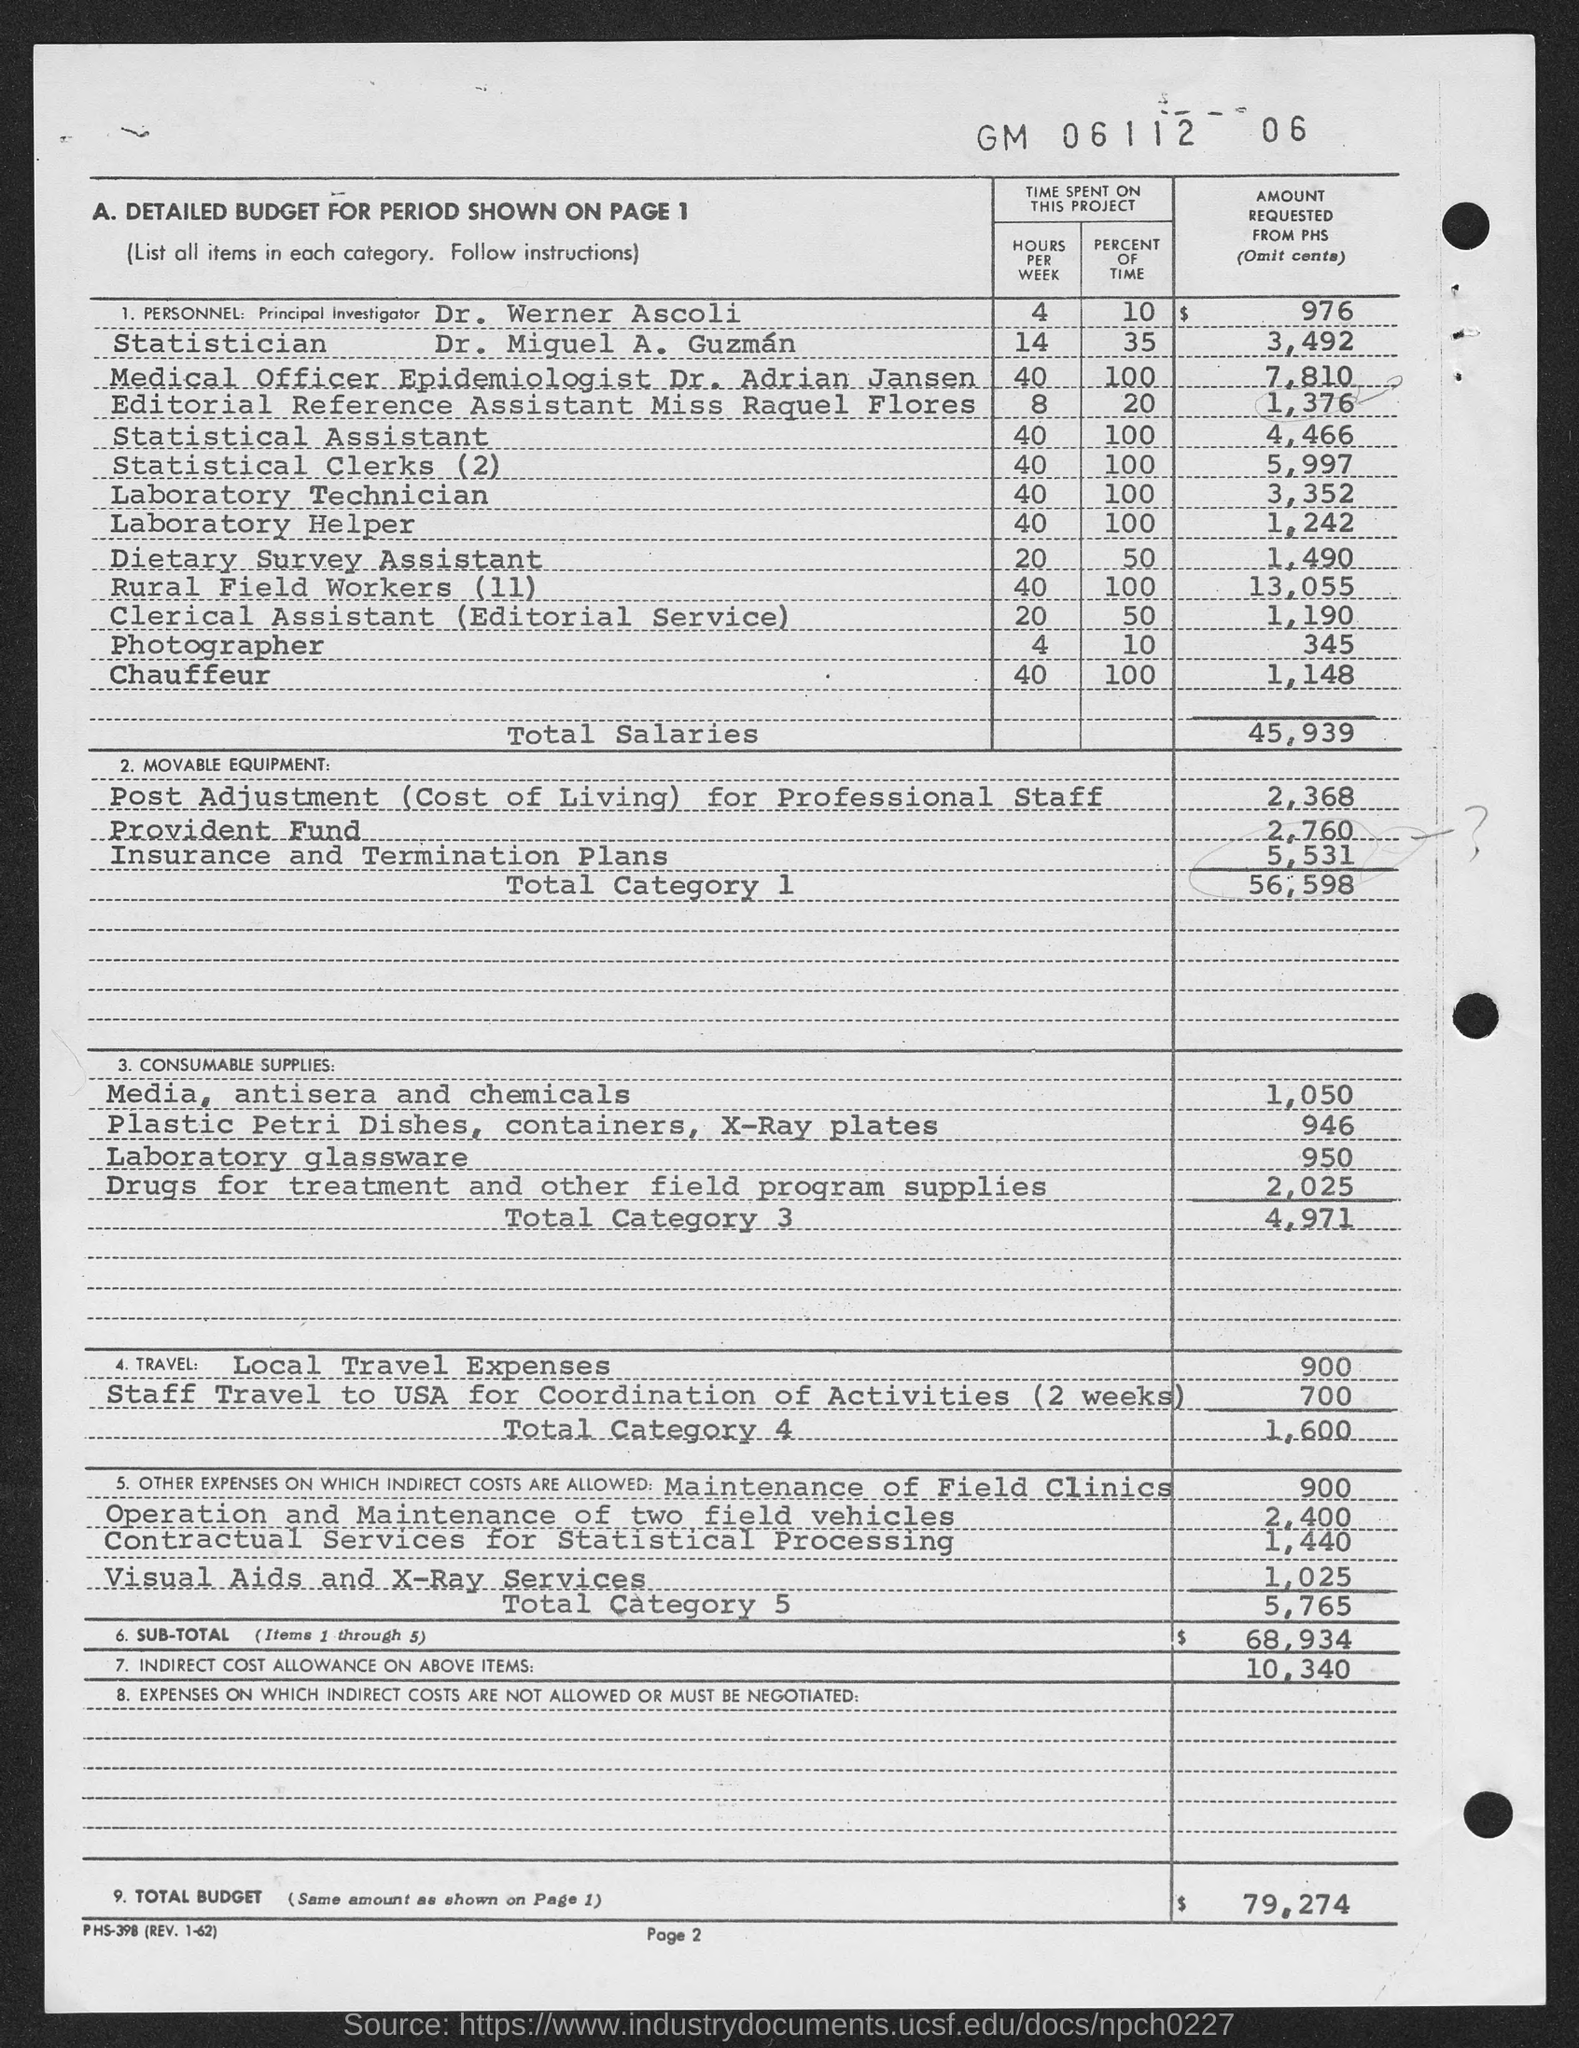What is the name of the principal investigator given in the document?
Your answer should be very brief. Dr. Werner Ascoli. What is the designation of Dr. Adrian Jansen?
Keep it short and to the point. Medical Officer Epidemiologist. What percent of time is spent on this project by Dr. Werner Ascoli?
Offer a terse response. 10. What percent of time is spent on this project by Dr. Adrian Jansen?
Your response must be concise. 100. Who is the Editorial Reference Assistant as per the document?
Provide a short and direct response. Miss Raquel Flores. How many hours per week is spent on this project by Miss Raquel Flores?
Give a very brief answer. 8. What is the toal budget amount requested from PHS?
Keep it short and to the point. $  79,274. 